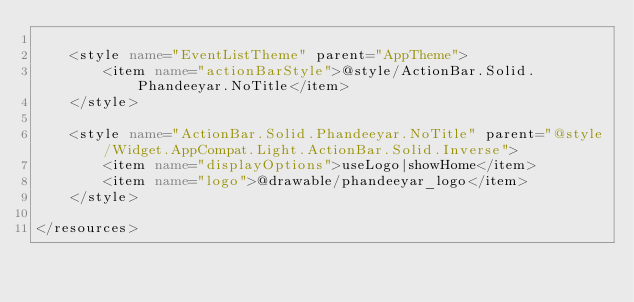<code> <loc_0><loc_0><loc_500><loc_500><_XML_>
    <style name="EventListTheme" parent="AppTheme">
        <item name="actionBarStyle">@style/ActionBar.Solid.Phandeeyar.NoTitle</item>
    </style>

    <style name="ActionBar.Solid.Phandeeyar.NoTitle" parent="@style/Widget.AppCompat.Light.ActionBar.Solid.Inverse">
        <item name="displayOptions">useLogo|showHome</item>
        <item name="logo">@drawable/phandeeyar_logo</item>
    </style>

</resources>
</code> 